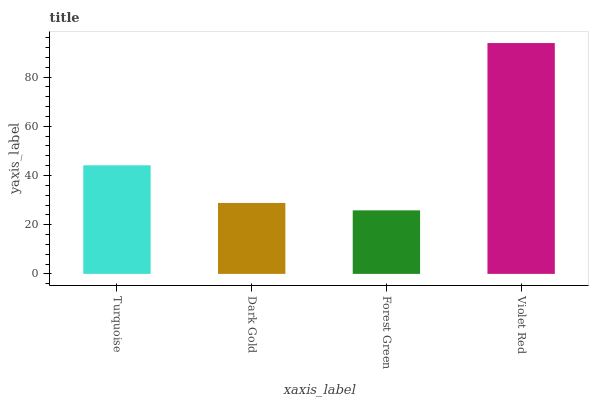Is Forest Green the minimum?
Answer yes or no. Yes. Is Violet Red the maximum?
Answer yes or no. Yes. Is Dark Gold the minimum?
Answer yes or no. No. Is Dark Gold the maximum?
Answer yes or no. No. Is Turquoise greater than Dark Gold?
Answer yes or no. Yes. Is Dark Gold less than Turquoise?
Answer yes or no. Yes. Is Dark Gold greater than Turquoise?
Answer yes or no. No. Is Turquoise less than Dark Gold?
Answer yes or no. No. Is Turquoise the high median?
Answer yes or no. Yes. Is Dark Gold the low median?
Answer yes or no. Yes. Is Dark Gold the high median?
Answer yes or no. No. Is Violet Red the low median?
Answer yes or no. No. 